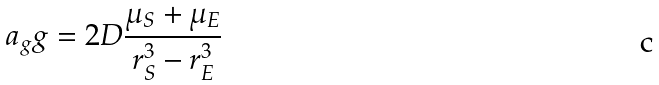Convert formula to latex. <formula><loc_0><loc_0><loc_500><loc_500>a _ { g } g = 2 D \frac { \mu _ { S } + \mu _ { E } } { r _ { S } ^ { 3 } - r _ { E } ^ { 3 } }</formula> 